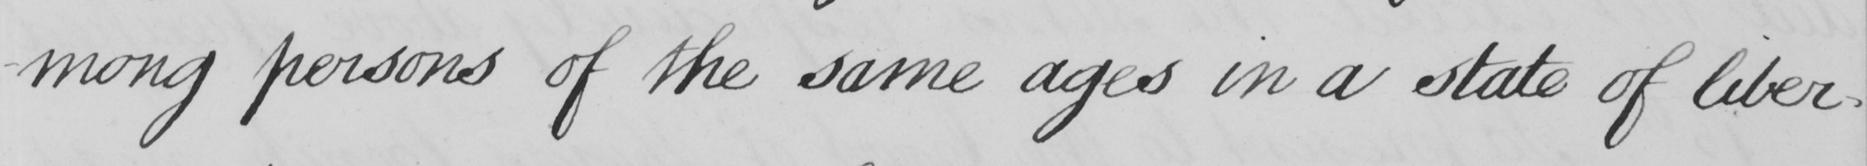Please transcribe the handwritten text in this image. -mong persons of the same ages in a state of liber- 